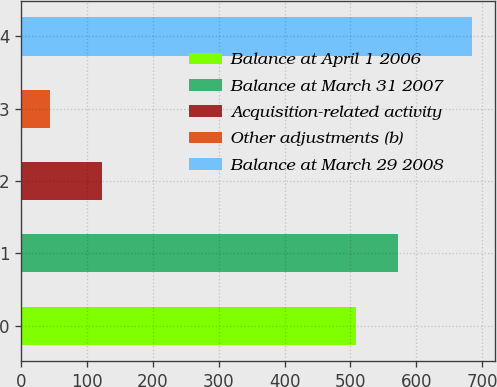Convert chart. <chart><loc_0><loc_0><loc_500><loc_500><bar_chart><fcel>Balance at April 1 2006<fcel>Balance at March 31 2007<fcel>Acquisition-related activity<fcel>Other adjustments (b)<fcel>Balance at March 29 2008<nl><fcel>507.8<fcel>571.94<fcel>122.5<fcel>43.4<fcel>684.8<nl></chart> 